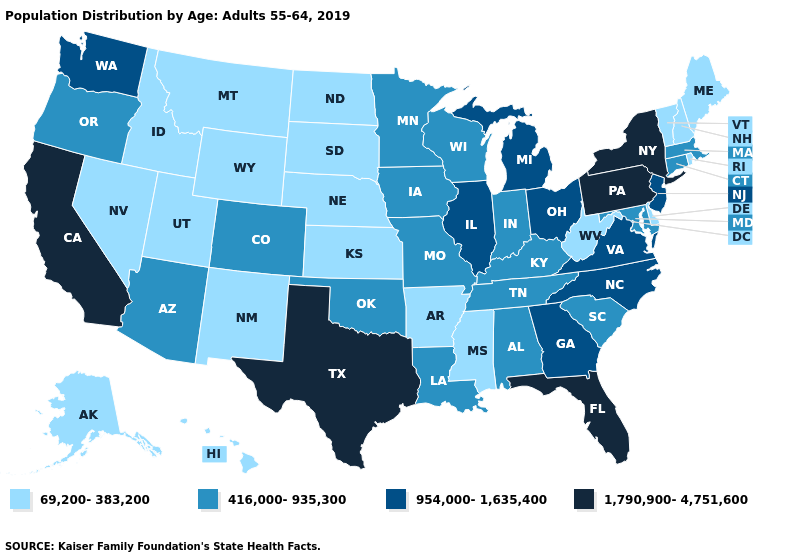What is the highest value in the USA?
Concise answer only. 1,790,900-4,751,600. Name the states that have a value in the range 69,200-383,200?
Write a very short answer. Alaska, Arkansas, Delaware, Hawaii, Idaho, Kansas, Maine, Mississippi, Montana, Nebraska, Nevada, New Hampshire, New Mexico, North Dakota, Rhode Island, South Dakota, Utah, Vermont, West Virginia, Wyoming. Does the first symbol in the legend represent the smallest category?
Short answer required. Yes. Name the states that have a value in the range 1,790,900-4,751,600?
Keep it brief. California, Florida, New York, Pennsylvania, Texas. Name the states that have a value in the range 954,000-1,635,400?
Quick response, please. Georgia, Illinois, Michigan, New Jersey, North Carolina, Ohio, Virginia, Washington. Does Maryland have the lowest value in the South?
Answer briefly. No. Name the states that have a value in the range 954,000-1,635,400?
Quick response, please. Georgia, Illinois, Michigan, New Jersey, North Carolina, Ohio, Virginia, Washington. Does Illinois have a lower value than Florida?
Keep it brief. Yes. What is the lowest value in states that border Ohio?
Answer briefly. 69,200-383,200. Does New York have the lowest value in the Northeast?
Give a very brief answer. No. What is the value of Wisconsin?
Quick response, please. 416,000-935,300. Among the states that border Nebraska , does Colorado have the lowest value?
Be succinct. No. Does Alaska have a lower value than New Hampshire?
Short answer required. No. Which states have the highest value in the USA?
Write a very short answer. California, Florida, New York, Pennsylvania, Texas. Name the states that have a value in the range 954,000-1,635,400?
Answer briefly. Georgia, Illinois, Michigan, New Jersey, North Carolina, Ohio, Virginia, Washington. 